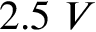<formula> <loc_0><loc_0><loc_500><loc_500>2 . 5 V</formula> 